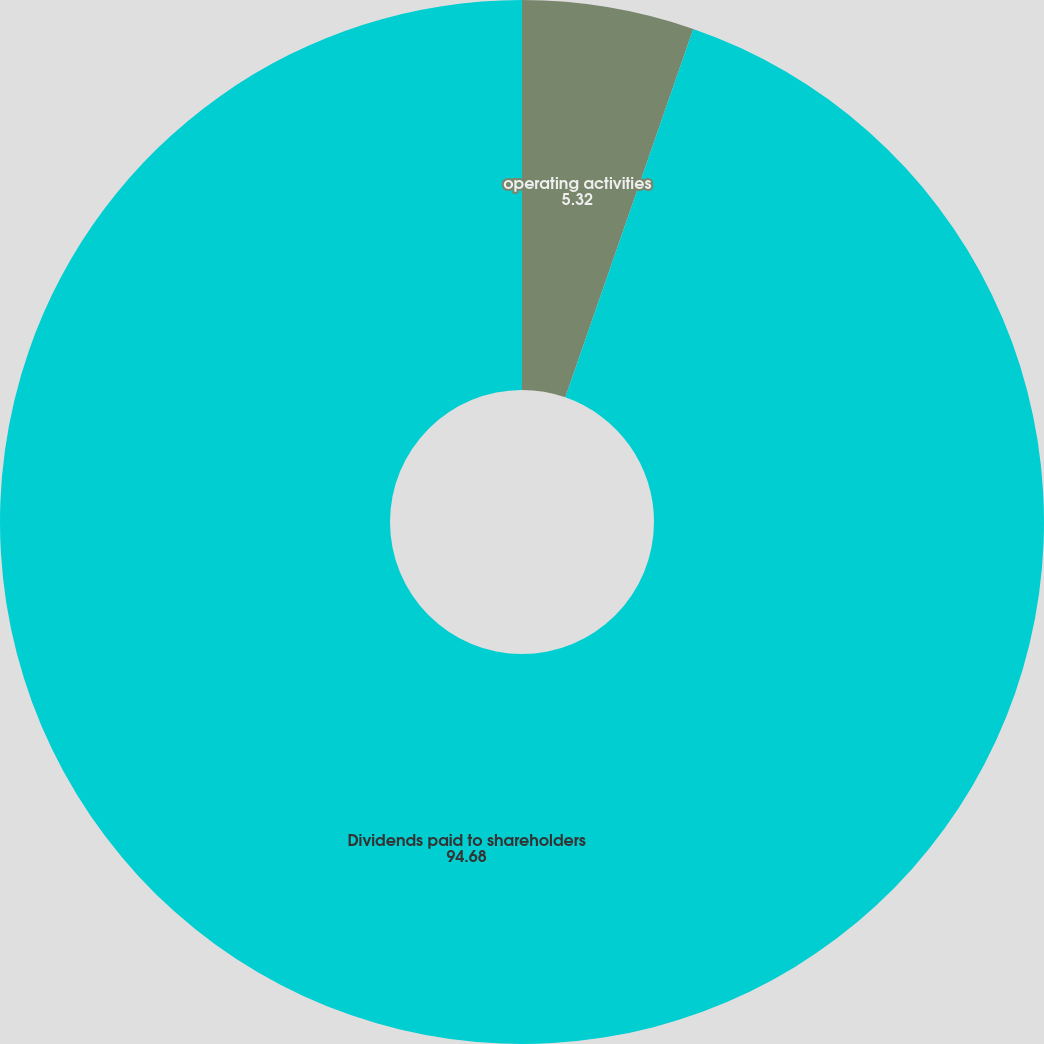<chart> <loc_0><loc_0><loc_500><loc_500><pie_chart><fcel>operating activities<fcel>Dividends paid to shareholders<nl><fcel>5.32%<fcel>94.68%<nl></chart> 